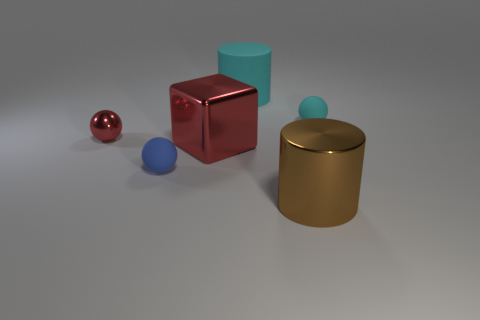Add 1 big red shiny cubes. How many objects exist? 7 Subtract all cylinders. How many objects are left? 4 Subtract all large red metallic cubes. Subtract all red objects. How many objects are left? 3 Add 6 metal cylinders. How many metal cylinders are left? 7 Add 6 blue spheres. How many blue spheres exist? 7 Subtract 1 red cubes. How many objects are left? 5 